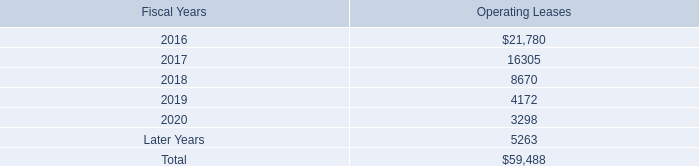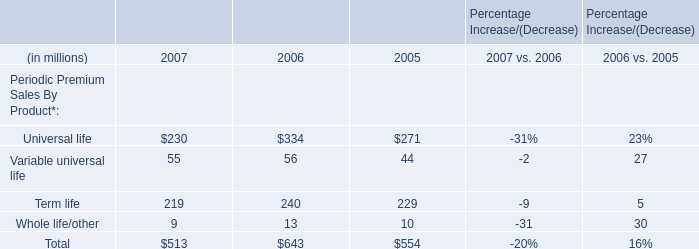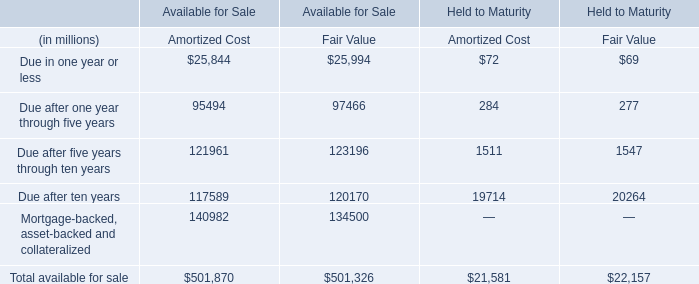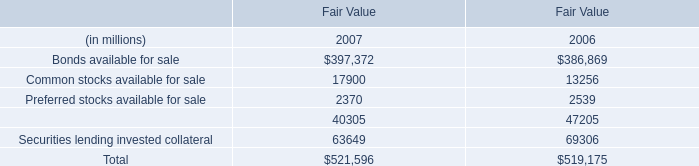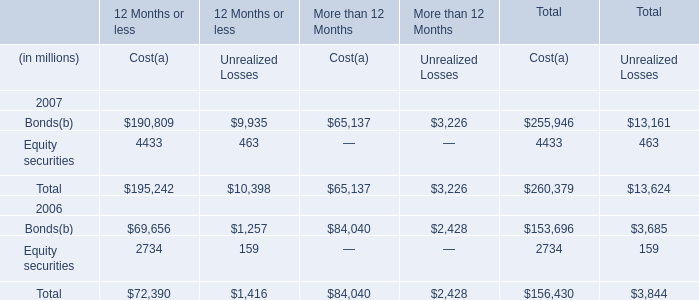In the year with largest amount of Bonds available , what's the increasing rate of Common stocks available? (in %) 
Computations: ((17900 - 13256) / 13256)
Answer: 0.35033. 